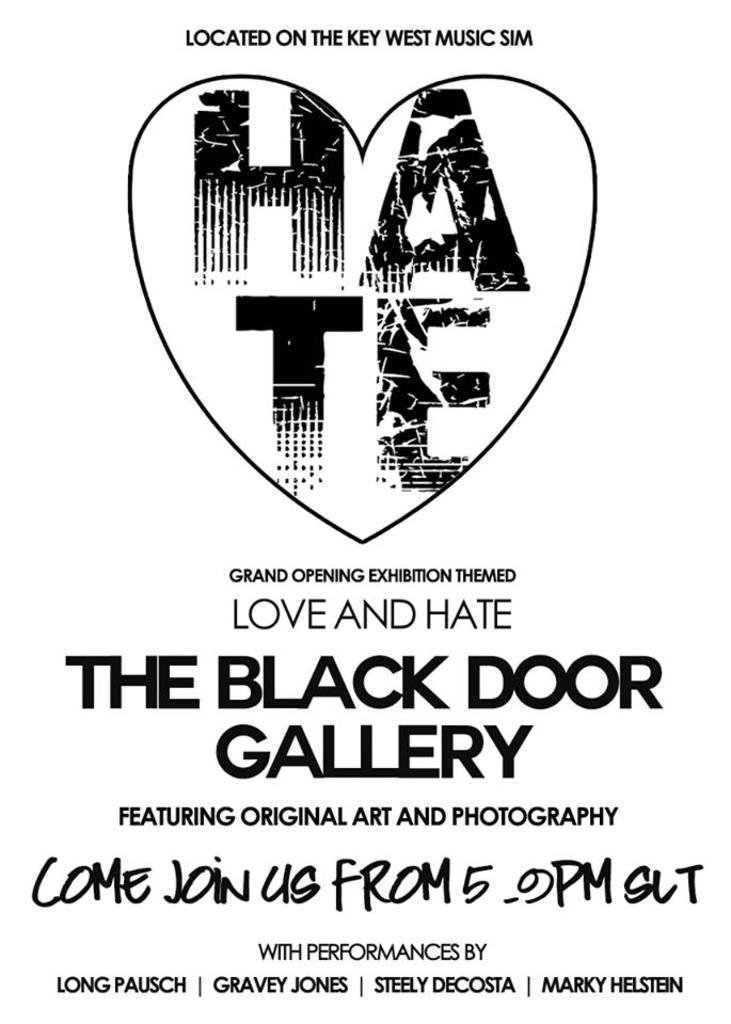<image>
Share a concise interpretation of the image provided. a poster for Love and Hate with a logo of a heart on it 